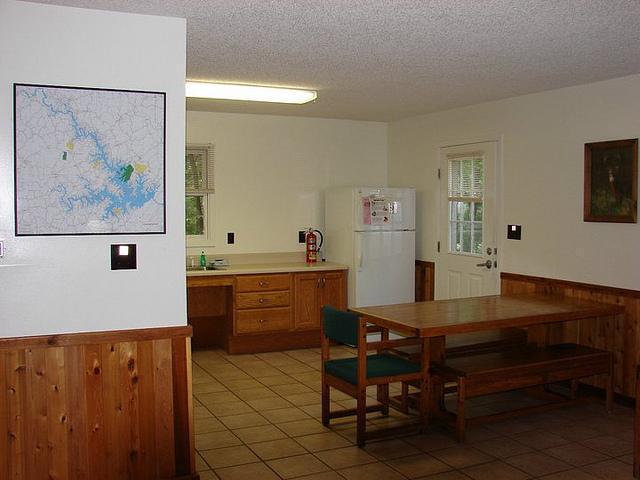How many chairs are in the scene?
Give a very brief answer. 1. How many entry doors do you see?
Give a very brief answer. 1. How many chairs are there at the table?
Give a very brief answer. 1. How many chairs are in the photo?
Give a very brief answer. 1. How many chairs are there?
Give a very brief answer. 1. How many chairs are visible in the dining room?
Give a very brief answer. 1. How many lights are over the island?
Give a very brief answer. 1. How many bowls are on the table?
Give a very brief answer. 0. 